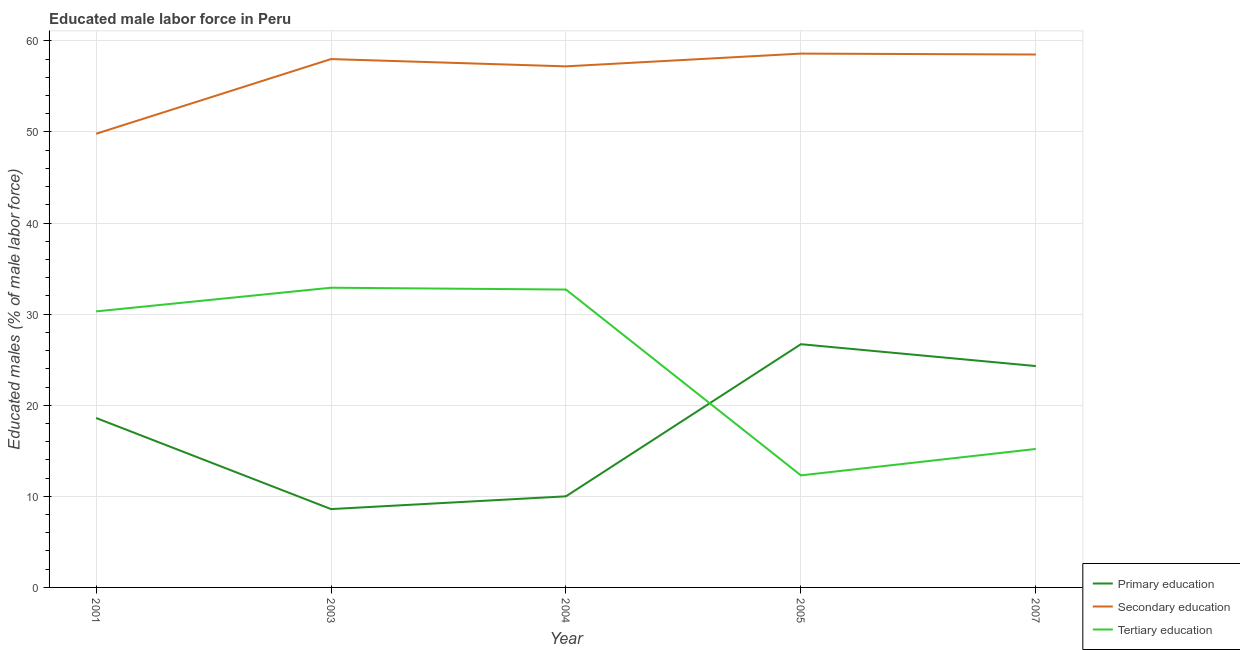How many different coloured lines are there?
Keep it short and to the point. 3. Does the line corresponding to percentage of male labor force who received tertiary education intersect with the line corresponding to percentage of male labor force who received primary education?
Your response must be concise. Yes. Is the number of lines equal to the number of legend labels?
Offer a terse response. Yes. What is the percentage of male labor force who received primary education in 2007?
Provide a short and direct response. 24.3. Across all years, what is the maximum percentage of male labor force who received tertiary education?
Keep it short and to the point. 32.9. Across all years, what is the minimum percentage of male labor force who received secondary education?
Keep it short and to the point. 49.8. In which year was the percentage of male labor force who received primary education maximum?
Offer a terse response. 2005. What is the total percentage of male labor force who received secondary education in the graph?
Offer a very short reply. 282.1. What is the difference between the percentage of male labor force who received primary education in 2001 and that in 2003?
Provide a succinct answer. 10. What is the difference between the percentage of male labor force who received primary education in 2004 and the percentage of male labor force who received secondary education in 2003?
Your answer should be compact. -48. What is the average percentage of male labor force who received tertiary education per year?
Offer a very short reply. 24.68. In the year 2007, what is the difference between the percentage of male labor force who received tertiary education and percentage of male labor force who received primary education?
Your answer should be very brief. -9.1. In how many years, is the percentage of male labor force who received tertiary education greater than 54 %?
Ensure brevity in your answer.  0. What is the ratio of the percentage of male labor force who received secondary education in 2001 to that in 2005?
Offer a very short reply. 0.85. Is the difference between the percentage of male labor force who received tertiary education in 2003 and 2005 greater than the difference between the percentage of male labor force who received primary education in 2003 and 2005?
Ensure brevity in your answer.  Yes. What is the difference between the highest and the second highest percentage of male labor force who received secondary education?
Ensure brevity in your answer.  0.1. What is the difference between the highest and the lowest percentage of male labor force who received secondary education?
Give a very brief answer. 8.8. In how many years, is the percentage of male labor force who received tertiary education greater than the average percentage of male labor force who received tertiary education taken over all years?
Your answer should be very brief. 3. Is the percentage of male labor force who received primary education strictly greater than the percentage of male labor force who received secondary education over the years?
Provide a short and direct response. No. Is the percentage of male labor force who received secondary education strictly less than the percentage of male labor force who received tertiary education over the years?
Offer a very short reply. No. What is the difference between two consecutive major ticks on the Y-axis?
Offer a very short reply. 10. Are the values on the major ticks of Y-axis written in scientific E-notation?
Keep it short and to the point. No. Where does the legend appear in the graph?
Offer a very short reply. Bottom right. How many legend labels are there?
Your response must be concise. 3. What is the title of the graph?
Give a very brief answer. Educated male labor force in Peru. What is the label or title of the X-axis?
Make the answer very short. Year. What is the label or title of the Y-axis?
Provide a short and direct response. Educated males (% of male labor force). What is the Educated males (% of male labor force) of Primary education in 2001?
Your answer should be compact. 18.6. What is the Educated males (% of male labor force) in Secondary education in 2001?
Offer a very short reply. 49.8. What is the Educated males (% of male labor force) of Tertiary education in 2001?
Your answer should be very brief. 30.3. What is the Educated males (% of male labor force) of Primary education in 2003?
Your response must be concise. 8.6. What is the Educated males (% of male labor force) of Secondary education in 2003?
Offer a terse response. 58. What is the Educated males (% of male labor force) in Tertiary education in 2003?
Provide a succinct answer. 32.9. What is the Educated males (% of male labor force) of Primary education in 2004?
Your response must be concise. 10. What is the Educated males (% of male labor force) of Secondary education in 2004?
Your response must be concise. 57.2. What is the Educated males (% of male labor force) of Tertiary education in 2004?
Ensure brevity in your answer.  32.7. What is the Educated males (% of male labor force) in Primary education in 2005?
Your answer should be compact. 26.7. What is the Educated males (% of male labor force) in Secondary education in 2005?
Ensure brevity in your answer.  58.6. What is the Educated males (% of male labor force) in Tertiary education in 2005?
Your response must be concise. 12.3. What is the Educated males (% of male labor force) in Primary education in 2007?
Ensure brevity in your answer.  24.3. What is the Educated males (% of male labor force) in Secondary education in 2007?
Provide a succinct answer. 58.5. What is the Educated males (% of male labor force) in Tertiary education in 2007?
Ensure brevity in your answer.  15.2. Across all years, what is the maximum Educated males (% of male labor force) of Primary education?
Your answer should be very brief. 26.7. Across all years, what is the maximum Educated males (% of male labor force) in Secondary education?
Your response must be concise. 58.6. Across all years, what is the maximum Educated males (% of male labor force) in Tertiary education?
Keep it short and to the point. 32.9. Across all years, what is the minimum Educated males (% of male labor force) of Primary education?
Offer a very short reply. 8.6. Across all years, what is the minimum Educated males (% of male labor force) in Secondary education?
Ensure brevity in your answer.  49.8. Across all years, what is the minimum Educated males (% of male labor force) of Tertiary education?
Make the answer very short. 12.3. What is the total Educated males (% of male labor force) of Primary education in the graph?
Your response must be concise. 88.2. What is the total Educated males (% of male labor force) of Secondary education in the graph?
Ensure brevity in your answer.  282.1. What is the total Educated males (% of male labor force) of Tertiary education in the graph?
Your answer should be very brief. 123.4. What is the difference between the Educated males (% of male labor force) in Primary education in 2001 and that in 2003?
Keep it short and to the point. 10. What is the difference between the Educated males (% of male labor force) of Secondary education in 2001 and that in 2003?
Offer a terse response. -8.2. What is the difference between the Educated males (% of male labor force) of Tertiary education in 2001 and that in 2004?
Your answer should be compact. -2.4. What is the difference between the Educated males (% of male labor force) of Secondary education in 2001 and that in 2005?
Offer a terse response. -8.8. What is the difference between the Educated males (% of male labor force) of Primary education in 2001 and that in 2007?
Your answer should be very brief. -5.7. What is the difference between the Educated males (% of male labor force) in Secondary education in 2001 and that in 2007?
Make the answer very short. -8.7. What is the difference between the Educated males (% of male labor force) in Tertiary education in 2001 and that in 2007?
Keep it short and to the point. 15.1. What is the difference between the Educated males (% of male labor force) of Primary education in 2003 and that in 2004?
Give a very brief answer. -1.4. What is the difference between the Educated males (% of male labor force) in Secondary education in 2003 and that in 2004?
Provide a succinct answer. 0.8. What is the difference between the Educated males (% of male labor force) in Primary education in 2003 and that in 2005?
Make the answer very short. -18.1. What is the difference between the Educated males (% of male labor force) of Secondary education in 2003 and that in 2005?
Your answer should be compact. -0.6. What is the difference between the Educated males (% of male labor force) in Tertiary education in 2003 and that in 2005?
Your response must be concise. 20.6. What is the difference between the Educated males (% of male labor force) in Primary education in 2003 and that in 2007?
Provide a short and direct response. -15.7. What is the difference between the Educated males (% of male labor force) in Primary education in 2004 and that in 2005?
Make the answer very short. -16.7. What is the difference between the Educated males (% of male labor force) of Tertiary education in 2004 and that in 2005?
Your answer should be compact. 20.4. What is the difference between the Educated males (% of male labor force) in Primary education in 2004 and that in 2007?
Ensure brevity in your answer.  -14.3. What is the difference between the Educated males (% of male labor force) in Primary education in 2001 and the Educated males (% of male labor force) in Secondary education in 2003?
Give a very brief answer. -39.4. What is the difference between the Educated males (% of male labor force) of Primary education in 2001 and the Educated males (% of male labor force) of Tertiary education in 2003?
Provide a succinct answer. -14.3. What is the difference between the Educated males (% of male labor force) of Secondary education in 2001 and the Educated males (% of male labor force) of Tertiary education in 2003?
Provide a succinct answer. 16.9. What is the difference between the Educated males (% of male labor force) of Primary education in 2001 and the Educated males (% of male labor force) of Secondary education in 2004?
Offer a very short reply. -38.6. What is the difference between the Educated males (% of male labor force) of Primary education in 2001 and the Educated males (% of male labor force) of Tertiary education in 2004?
Offer a very short reply. -14.1. What is the difference between the Educated males (% of male labor force) in Secondary education in 2001 and the Educated males (% of male labor force) in Tertiary education in 2004?
Offer a very short reply. 17.1. What is the difference between the Educated males (% of male labor force) in Primary education in 2001 and the Educated males (% of male labor force) in Tertiary education in 2005?
Give a very brief answer. 6.3. What is the difference between the Educated males (% of male labor force) of Secondary education in 2001 and the Educated males (% of male labor force) of Tertiary education in 2005?
Give a very brief answer. 37.5. What is the difference between the Educated males (% of male labor force) in Primary education in 2001 and the Educated males (% of male labor force) in Secondary education in 2007?
Your answer should be compact. -39.9. What is the difference between the Educated males (% of male labor force) in Primary education in 2001 and the Educated males (% of male labor force) in Tertiary education in 2007?
Give a very brief answer. 3.4. What is the difference between the Educated males (% of male labor force) of Secondary education in 2001 and the Educated males (% of male labor force) of Tertiary education in 2007?
Offer a very short reply. 34.6. What is the difference between the Educated males (% of male labor force) in Primary education in 2003 and the Educated males (% of male labor force) in Secondary education in 2004?
Offer a terse response. -48.6. What is the difference between the Educated males (% of male labor force) of Primary education in 2003 and the Educated males (% of male labor force) of Tertiary education in 2004?
Your answer should be very brief. -24.1. What is the difference between the Educated males (% of male labor force) of Secondary education in 2003 and the Educated males (% of male labor force) of Tertiary education in 2004?
Provide a short and direct response. 25.3. What is the difference between the Educated males (% of male labor force) of Primary education in 2003 and the Educated males (% of male labor force) of Tertiary education in 2005?
Your answer should be compact. -3.7. What is the difference between the Educated males (% of male labor force) of Secondary education in 2003 and the Educated males (% of male labor force) of Tertiary education in 2005?
Your response must be concise. 45.7. What is the difference between the Educated males (% of male labor force) in Primary education in 2003 and the Educated males (% of male labor force) in Secondary education in 2007?
Offer a very short reply. -49.9. What is the difference between the Educated males (% of male labor force) of Secondary education in 2003 and the Educated males (% of male labor force) of Tertiary education in 2007?
Ensure brevity in your answer.  42.8. What is the difference between the Educated males (% of male labor force) of Primary education in 2004 and the Educated males (% of male labor force) of Secondary education in 2005?
Your response must be concise. -48.6. What is the difference between the Educated males (% of male labor force) in Primary education in 2004 and the Educated males (% of male labor force) in Tertiary education in 2005?
Ensure brevity in your answer.  -2.3. What is the difference between the Educated males (% of male labor force) of Secondary education in 2004 and the Educated males (% of male labor force) of Tertiary education in 2005?
Provide a short and direct response. 44.9. What is the difference between the Educated males (% of male labor force) of Primary education in 2004 and the Educated males (% of male labor force) of Secondary education in 2007?
Provide a succinct answer. -48.5. What is the difference between the Educated males (% of male labor force) of Primary education in 2004 and the Educated males (% of male labor force) of Tertiary education in 2007?
Offer a terse response. -5.2. What is the difference between the Educated males (% of male labor force) of Primary education in 2005 and the Educated males (% of male labor force) of Secondary education in 2007?
Give a very brief answer. -31.8. What is the difference between the Educated males (% of male labor force) in Secondary education in 2005 and the Educated males (% of male labor force) in Tertiary education in 2007?
Provide a succinct answer. 43.4. What is the average Educated males (% of male labor force) of Primary education per year?
Your answer should be compact. 17.64. What is the average Educated males (% of male labor force) of Secondary education per year?
Provide a short and direct response. 56.42. What is the average Educated males (% of male labor force) of Tertiary education per year?
Provide a short and direct response. 24.68. In the year 2001, what is the difference between the Educated males (% of male labor force) of Primary education and Educated males (% of male labor force) of Secondary education?
Make the answer very short. -31.2. In the year 2001, what is the difference between the Educated males (% of male labor force) in Primary education and Educated males (% of male labor force) in Tertiary education?
Your response must be concise. -11.7. In the year 2003, what is the difference between the Educated males (% of male labor force) of Primary education and Educated males (% of male labor force) of Secondary education?
Keep it short and to the point. -49.4. In the year 2003, what is the difference between the Educated males (% of male labor force) in Primary education and Educated males (% of male labor force) in Tertiary education?
Provide a succinct answer. -24.3. In the year 2003, what is the difference between the Educated males (% of male labor force) of Secondary education and Educated males (% of male labor force) of Tertiary education?
Your answer should be very brief. 25.1. In the year 2004, what is the difference between the Educated males (% of male labor force) in Primary education and Educated males (% of male labor force) in Secondary education?
Provide a short and direct response. -47.2. In the year 2004, what is the difference between the Educated males (% of male labor force) of Primary education and Educated males (% of male labor force) of Tertiary education?
Your answer should be very brief. -22.7. In the year 2004, what is the difference between the Educated males (% of male labor force) in Secondary education and Educated males (% of male labor force) in Tertiary education?
Your answer should be very brief. 24.5. In the year 2005, what is the difference between the Educated males (% of male labor force) of Primary education and Educated males (% of male labor force) of Secondary education?
Ensure brevity in your answer.  -31.9. In the year 2005, what is the difference between the Educated males (% of male labor force) of Primary education and Educated males (% of male labor force) of Tertiary education?
Your answer should be compact. 14.4. In the year 2005, what is the difference between the Educated males (% of male labor force) in Secondary education and Educated males (% of male labor force) in Tertiary education?
Provide a succinct answer. 46.3. In the year 2007, what is the difference between the Educated males (% of male labor force) in Primary education and Educated males (% of male labor force) in Secondary education?
Give a very brief answer. -34.2. In the year 2007, what is the difference between the Educated males (% of male labor force) of Secondary education and Educated males (% of male labor force) of Tertiary education?
Your answer should be compact. 43.3. What is the ratio of the Educated males (% of male labor force) of Primary education in 2001 to that in 2003?
Offer a terse response. 2.16. What is the ratio of the Educated males (% of male labor force) of Secondary education in 2001 to that in 2003?
Give a very brief answer. 0.86. What is the ratio of the Educated males (% of male labor force) in Tertiary education in 2001 to that in 2003?
Provide a short and direct response. 0.92. What is the ratio of the Educated males (% of male labor force) of Primary education in 2001 to that in 2004?
Your answer should be very brief. 1.86. What is the ratio of the Educated males (% of male labor force) of Secondary education in 2001 to that in 2004?
Offer a very short reply. 0.87. What is the ratio of the Educated males (% of male labor force) of Tertiary education in 2001 to that in 2004?
Your answer should be compact. 0.93. What is the ratio of the Educated males (% of male labor force) of Primary education in 2001 to that in 2005?
Keep it short and to the point. 0.7. What is the ratio of the Educated males (% of male labor force) in Secondary education in 2001 to that in 2005?
Keep it short and to the point. 0.85. What is the ratio of the Educated males (% of male labor force) of Tertiary education in 2001 to that in 2005?
Provide a short and direct response. 2.46. What is the ratio of the Educated males (% of male labor force) in Primary education in 2001 to that in 2007?
Make the answer very short. 0.77. What is the ratio of the Educated males (% of male labor force) in Secondary education in 2001 to that in 2007?
Ensure brevity in your answer.  0.85. What is the ratio of the Educated males (% of male labor force) in Tertiary education in 2001 to that in 2007?
Offer a very short reply. 1.99. What is the ratio of the Educated males (% of male labor force) in Primary education in 2003 to that in 2004?
Keep it short and to the point. 0.86. What is the ratio of the Educated males (% of male labor force) in Secondary education in 2003 to that in 2004?
Your response must be concise. 1.01. What is the ratio of the Educated males (% of male labor force) in Tertiary education in 2003 to that in 2004?
Make the answer very short. 1.01. What is the ratio of the Educated males (% of male labor force) in Primary education in 2003 to that in 2005?
Your answer should be compact. 0.32. What is the ratio of the Educated males (% of male labor force) of Tertiary education in 2003 to that in 2005?
Keep it short and to the point. 2.67. What is the ratio of the Educated males (% of male labor force) of Primary education in 2003 to that in 2007?
Your answer should be compact. 0.35. What is the ratio of the Educated males (% of male labor force) in Tertiary education in 2003 to that in 2007?
Offer a very short reply. 2.16. What is the ratio of the Educated males (% of male labor force) of Primary education in 2004 to that in 2005?
Provide a succinct answer. 0.37. What is the ratio of the Educated males (% of male labor force) in Secondary education in 2004 to that in 2005?
Offer a terse response. 0.98. What is the ratio of the Educated males (% of male labor force) of Tertiary education in 2004 to that in 2005?
Give a very brief answer. 2.66. What is the ratio of the Educated males (% of male labor force) in Primary education in 2004 to that in 2007?
Make the answer very short. 0.41. What is the ratio of the Educated males (% of male labor force) of Secondary education in 2004 to that in 2007?
Offer a terse response. 0.98. What is the ratio of the Educated males (% of male labor force) of Tertiary education in 2004 to that in 2007?
Offer a very short reply. 2.15. What is the ratio of the Educated males (% of male labor force) of Primary education in 2005 to that in 2007?
Your answer should be very brief. 1.1. What is the ratio of the Educated males (% of male labor force) of Tertiary education in 2005 to that in 2007?
Offer a very short reply. 0.81. What is the difference between the highest and the second highest Educated males (% of male labor force) of Tertiary education?
Keep it short and to the point. 0.2. What is the difference between the highest and the lowest Educated males (% of male labor force) of Secondary education?
Offer a very short reply. 8.8. What is the difference between the highest and the lowest Educated males (% of male labor force) in Tertiary education?
Make the answer very short. 20.6. 